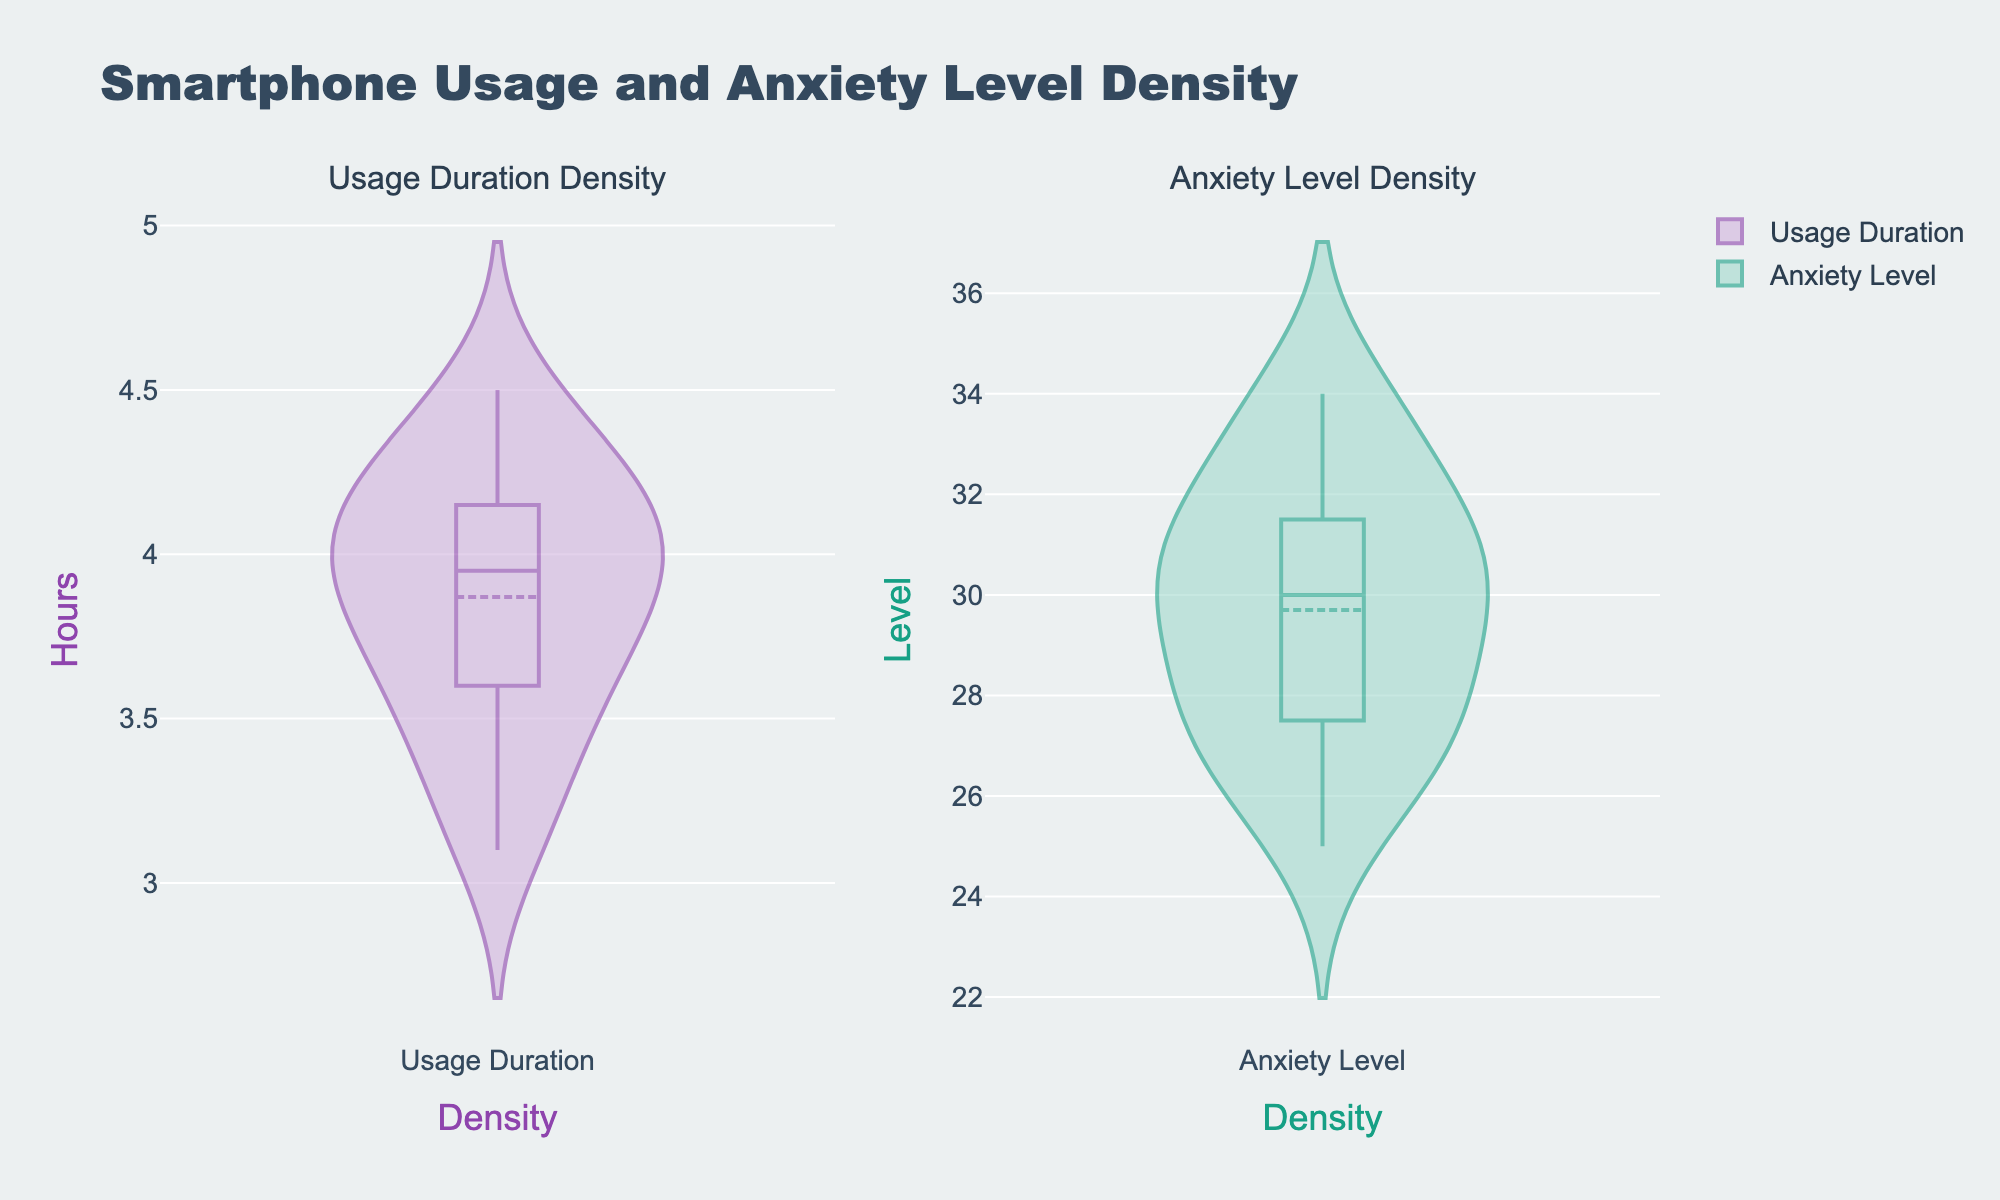What's the title of the figure? The title is prominently located at the top of the figure and reads "Smartphone Usage and Anxiety Level Density".
Answer: Smartphone Usage and Anxiety Level Density What's the color of the fill for the "Usage Duration" density plot? The fill color of the "Usage Duration" density plot is a light purple shade.
Answer: Light purple Which density plot has a higher meanline location? By observing the meanline positions, the "Anxiety Level" density plot has a higher meanline location compared to the "Usage Duration".
Answer: Anxiety Level What's the y-axis label of the "Anxiety Level Density" plot? The y-axis label for the "Anxiety Level Density" plot is "Level".
Answer: Level What's the meanline value for the "Usage Duration" density plot? The meanline value for "Usage Duration" is visible, centered around 4 hours on the y-axis.
Answer: 4 hours Compare the spread of the data in "Usage Duration" and "Anxiety Level" density plots. Which one is more spread out? The "Usage Duration" plot shows a more condensed spread around its meanline, whereas the "Anxiety Level" plot has a wider spread of data points around its meanline.
Answer: Anxiety Level What is the approximate peak value of the "Anxiety Level" density plot? The peak value for "Anxiety Level" is seen around Level 30 on the y-axis where the density is the highest.
Answer: 30 Considering both density plots, which y-axis has a higher maximum value? The y-axis of the "Anxiety Level" density plot reaches a higher maximum value (around 34) than the "Usage Duration" density plot (less than 5).
Answer: Anxiety Level Which density plot indicates more variability in the data based on the violin shape? The "Anxiety Level" density plot shows more variability because the shape of the violin plot is wider, indicating more spread in the data.
Answer: Anxiety Level 